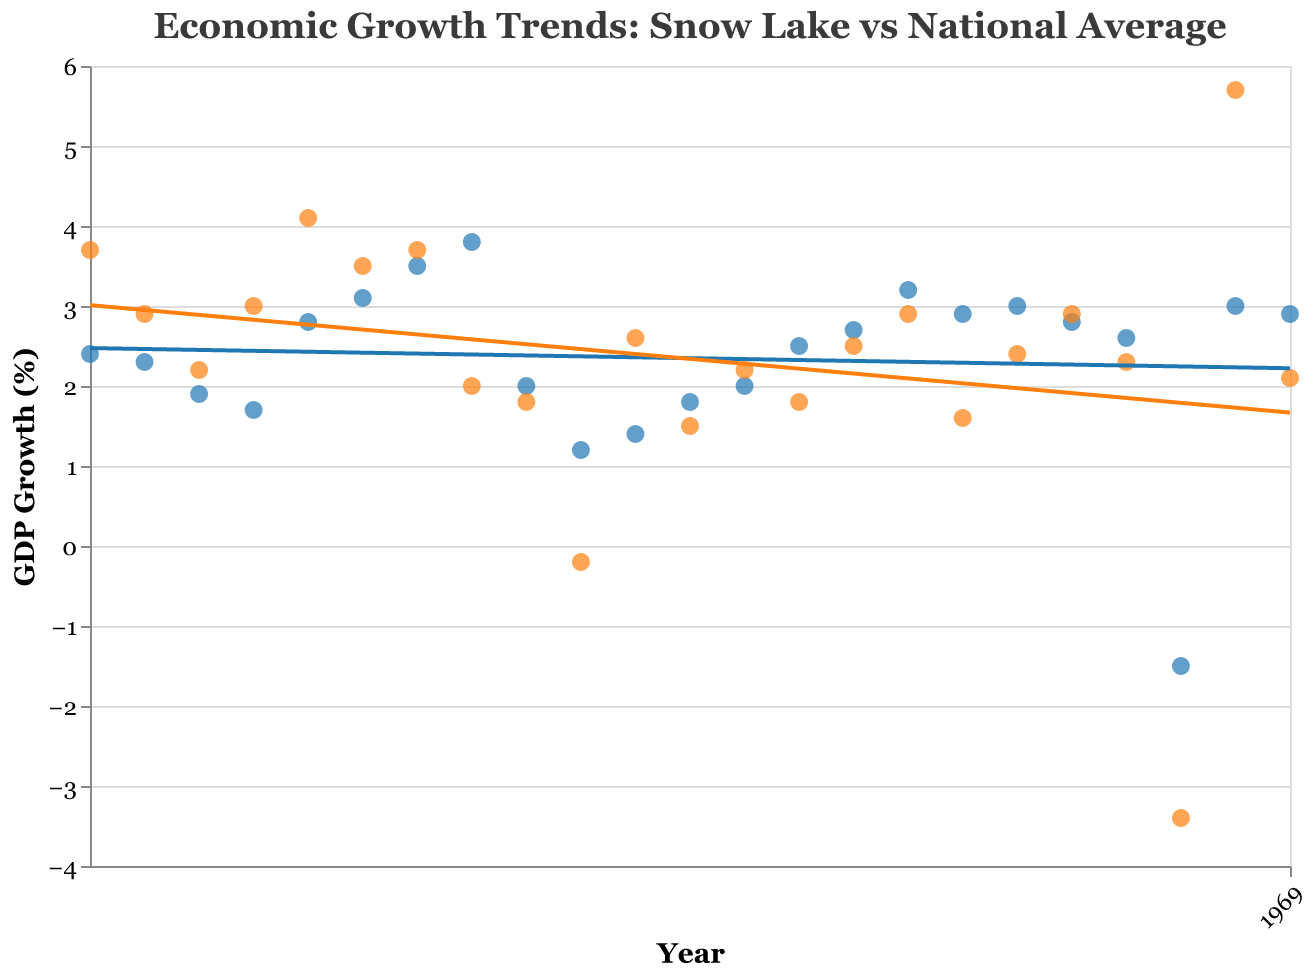What are the two variables being compared in the plot? The plot compares "Snow Lake GDP Growth (%)" and "National GDP Growth (%)" over a range of years from 2000 to 2022. This is evident from the title and the labels on the vertical axis.
Answer: GDP Growth of Snow Lake and National What is the highest point on the Snow Lake GDP Growth (%) trend line? A highest point on the Snow Lake GDP Growth (%) trend line can be identified by looking for the highest y-value for the Snow Lake data points. According to the data, the highest growth occurred in 2007 at 3.8%.
Answer: 3.8% in 2007 In which year did Snow Lake experience negative GDP growth, and how does it compare to the national GDP growth in the same year? Snow Lake experienced negative GDP growth in 2020, with a value of -1.5%. In that same year, the national GDP growth was also negative, at -3.4%.
Answer: 2020; -1.5% vs. -3.4% Which year shows the largest discrepancy between Snow Lake and national GDP growth? To find the year with the largest discrepancy, one needs to compute the absolute difference for each year and identify the maximum. The largest discrepancy occurs in 2021 with Snow Lake GDP Growth at 3.0% and National GDP Growth at 5.7%, a difference of 2.7%.
Answer: 2021 What is the average GDP growth rate for Snow Lake from 2000 to 2022? To calculate the average GDP growth rate for Snow Lake over the given period, sum the percentages and divide by the number of years. Sum: (2.4 + 2.3 + ... + 2.9) = 58.1, Number of years = 23. Average = 58.1 / 23 ≈ 2.53%
Answer: 2.53% How did Snow Lake's GDP growth rate compare to the national average in 2008? In 2008, Snow Lake had a GDP growth rate of 2.0%, while the national average was 1.8%. Snow Lake's growth rate was slightly higher than the national average.
Answer: Snow Lake was higher Looking at the trend lines, what can you infer about the long-term growth trends of Snow Lake compared to the national average? By examining the trend lines, one can infer that Snow Lake's GDP growth has been more stable and less volatile compared to the national average, with a generally upward trend. However, both experienced a significant dip around 2020.
Answer: Less volatile and more stable Between 2015 and 2019, which year did Snow Lake's GDP growth rate peak, and what was the rate? Within this period, Snow Lake's GDP growth rate peaked in 2015 at 3.2%.
Answer: 2015; 3.2% How does the GDP growth recovery in 2021 compare between Snow Lake and the national average? In 2021, Snow Lake's GDP growth rate was 3.0%, whereas the national GDP growth rate was 5.7%. This indicates that the national recovery was stronger after 2020.
Answer: National recovery was stronger 